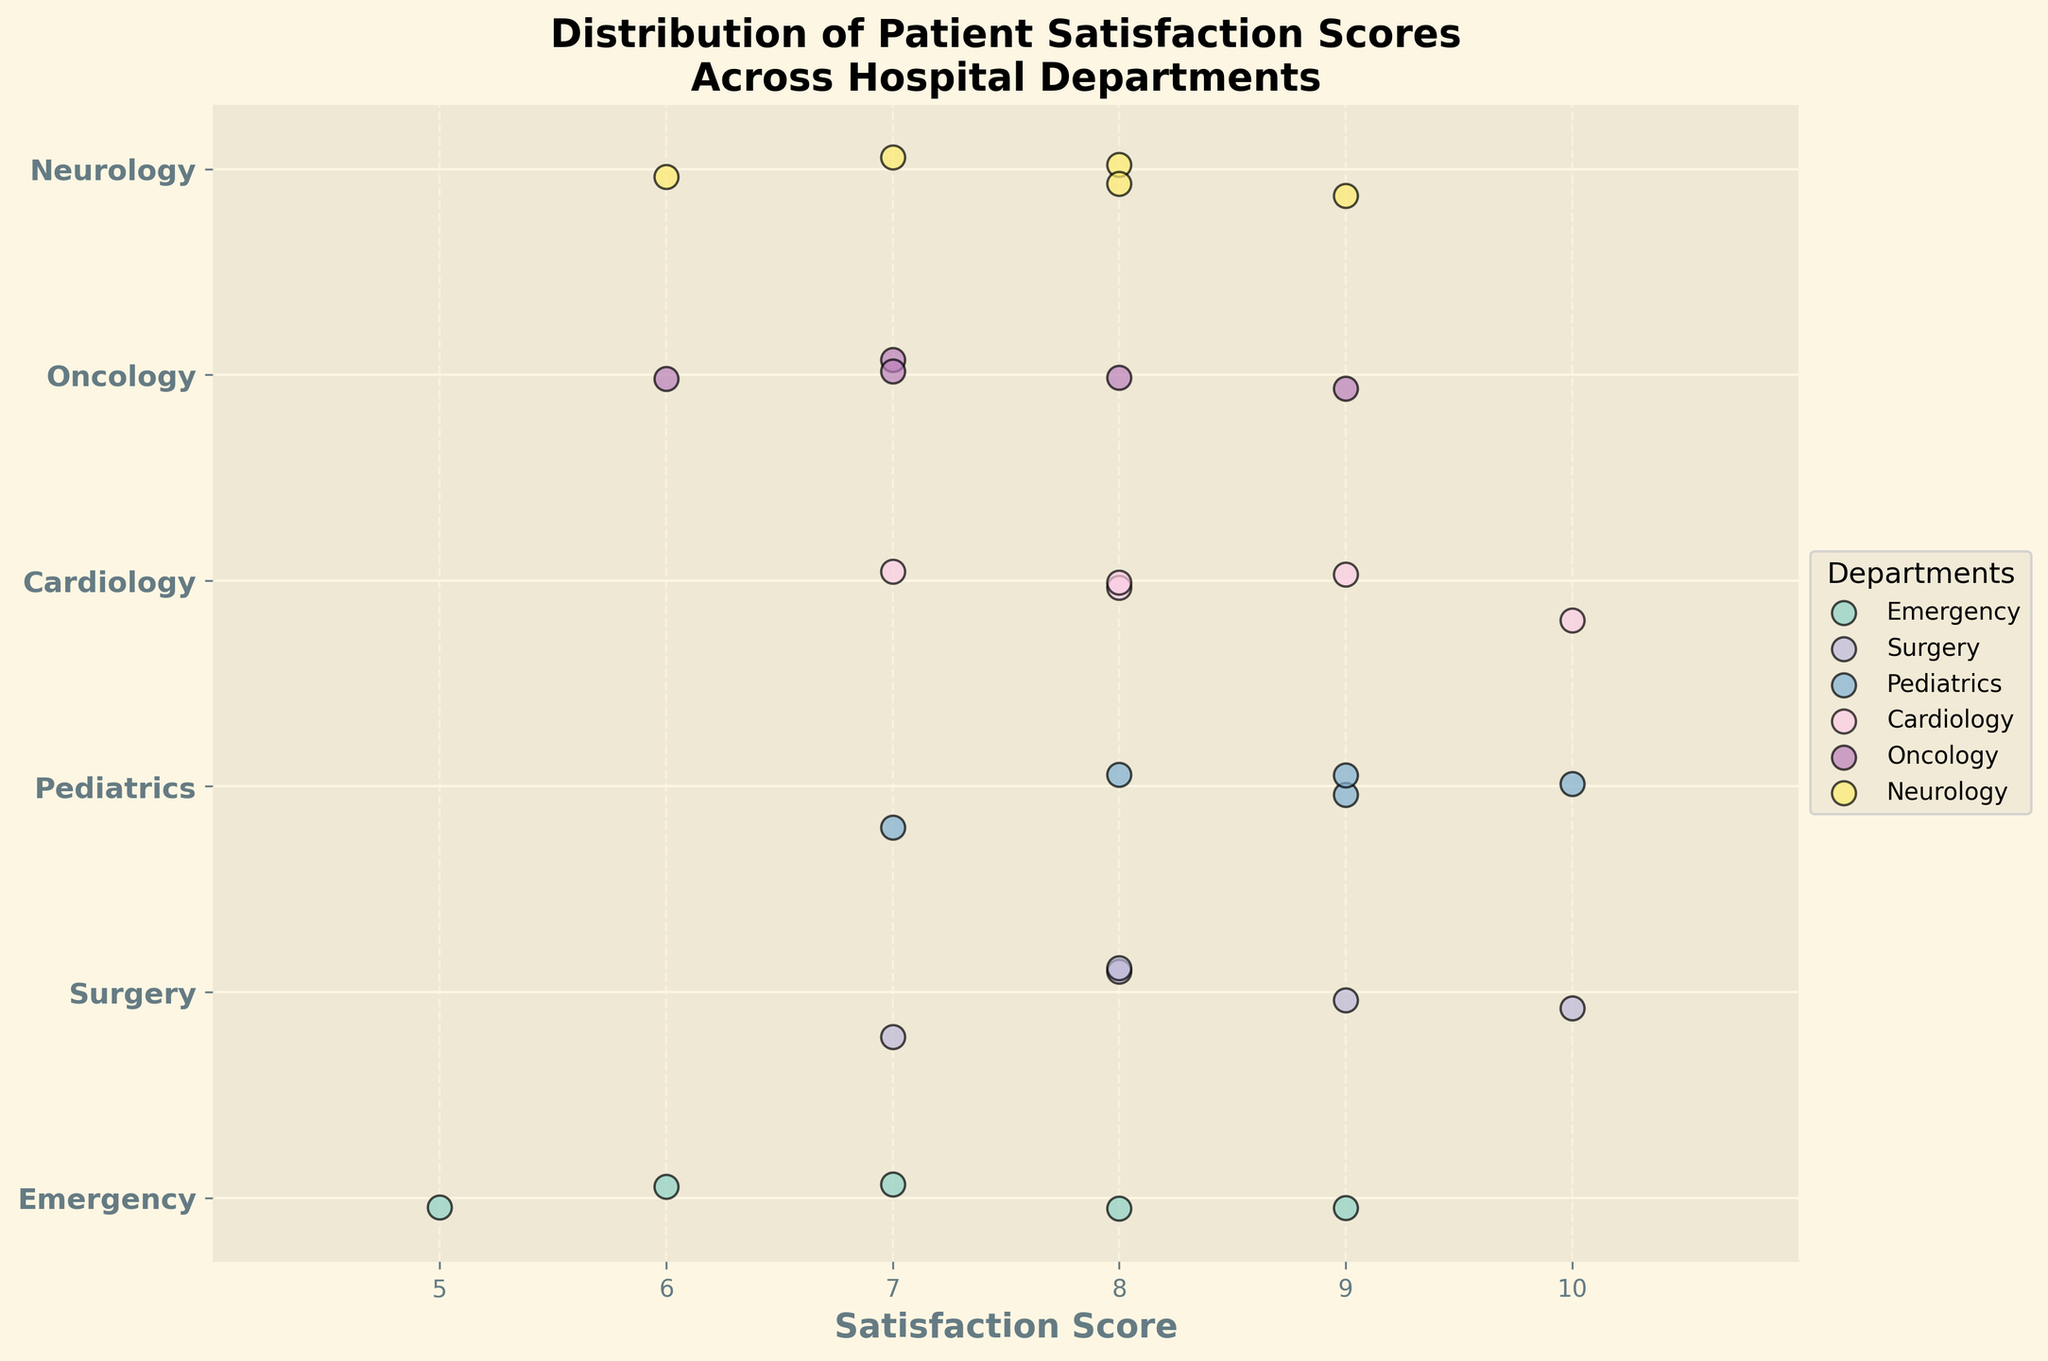What is the title of the figure? The title of the figure is written on the top of the plot and reads "Distribution of Patient Satisfaction Scores Across Hospital Departments."
Answer: "Distribution of Patient Satisfaction Scores Across Hospital Departments" Which department has the highest satisfaction score? By observing the scatter points on the x-axis, Pediatrics, Surgery, and Cardiology all have the highest satisfaction scores of 10.
Answer: Pediatrics, Surgery, and Cardiology What is the minimum satisfaction score in the Emergency department? Look at the scatter points for the Emergency department, which are around the y-axis for Emergency. The lowest x-axis value is 5.
Answer: 5 How many departments have the highest satisfaction score as 10? Identify the departments with x-axis scatter points reaching 10. These are Pediatrics, Surgery, and Cardiology. There are 3 departments in total.
Answer: 3 What is the range of satisfaction scores in the Oncology department? The satisfaction scores in the Oncology department range from the minimum value of 6 to the maximum value of 9.
Answer: 3 Which department has the most varied satisfaction scores within the range of 7 to 10? By observing the spread of points, the Oncology department has scores from 6 to 9, indicating a wider range compared to others.
Answer: Oncology Which departments have scores clustered mostly around the score of 8? Observe which departments have many points near the score of 8. Both Neurology and Surgery have several scores around 8.
Answer: Neurology and Surgery Compare the mean satisfaction score of Cardiology and Pediatrics. Which one is higher? Cardiology has scores: 8, 7, 9, 8, 10; the mean is (8+7+9+8+10)/5 = 8.4. Pediatrics has scores: 9, 8, 10, 9, 7; the mean is (9+8+10+9+7)/5 = 8.6. Pediatrics' mean is higher.
Answer: Pediatrics Which department shows the highest concentration of scores in the figure? Look for the departments with tightly grouped scatter points. The Emergency department shows scores tightly grouped around the 7-9 range, representing high concentration.
Answer: Emergency 